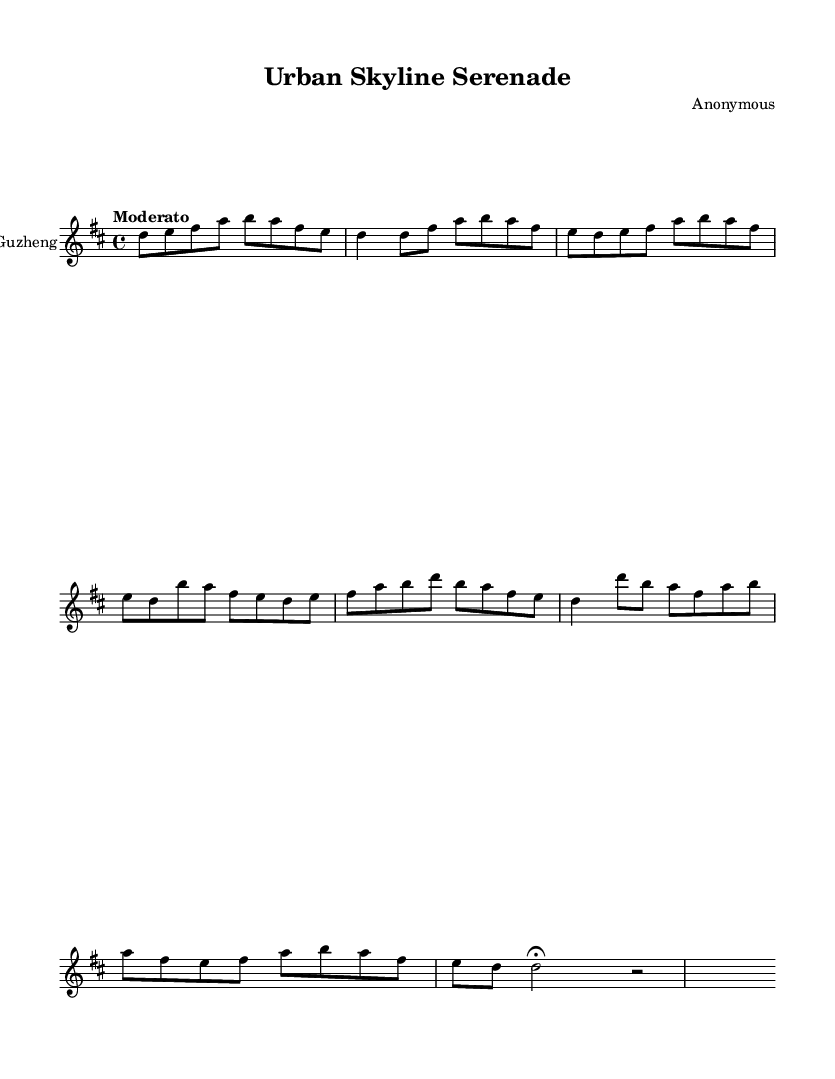What is the key signature of this music? The key signature indicated is D major, which has two sharps (F# and C#). This can be identified by looking at the key signature symbol at the beginning of the staff.
Answer: D major What is the time signature of this music? The time signature shown is 4/4, which means there are four beats in each measure and a quarter note gets one beat. This is evident from the notation displayed at the beginning of the score.
Answer: 4/4 What is the tempo marking for this piece? The tempo marking is "Moderato," which suggests a moderate pace for the music. This is specified in the score right above the staff.
Answer: Moderato How many sections does the music have? The music contains four sections: Introduction, A section, B section, and C section, followed by a Coda. This can be discerned from the structure laid out in the score, where different musical ideas are separated.
Answer: Four What is the highest note in the music? The highest note in the music is B, which can be identified by examining the note pitches written in the score, particularly in the B section where B' appears.
Answer: B What is the rhythmic pattern used predominantly in the A section? The predominant rhythmic pattern in the A section is eighth notes followed by a quarter note. This is deduced from the way the notes are grouped within measures in that section.
Answer: Eighth notes What is the relationship between the A and B sections in terms of melody? The A section features a stepwise upward and downward motion, while the B section introduces a more varied rhythm with longer notes and a mix of steps and leaps. This can be seen by comparing the note sequences in both sections.
Answer: Stepwise and varied 